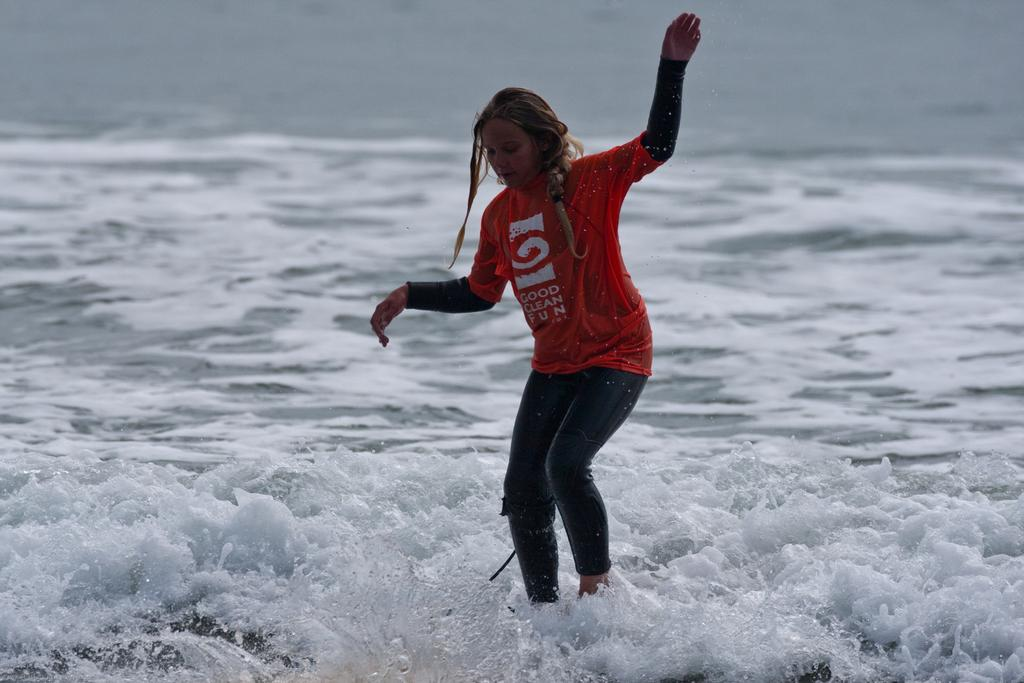What can be seen in the image? There is water visible in the image. Can you describe the woman in the image? There is a woman wearing a red t-shirt in the image. Where is the bell located in the image? There is no bell present in the image. What type of transportation is available at the airport shown in the image? There is no airport present in the image. Is the stove being used to cook anything in the image? There is no stove present in the image. 